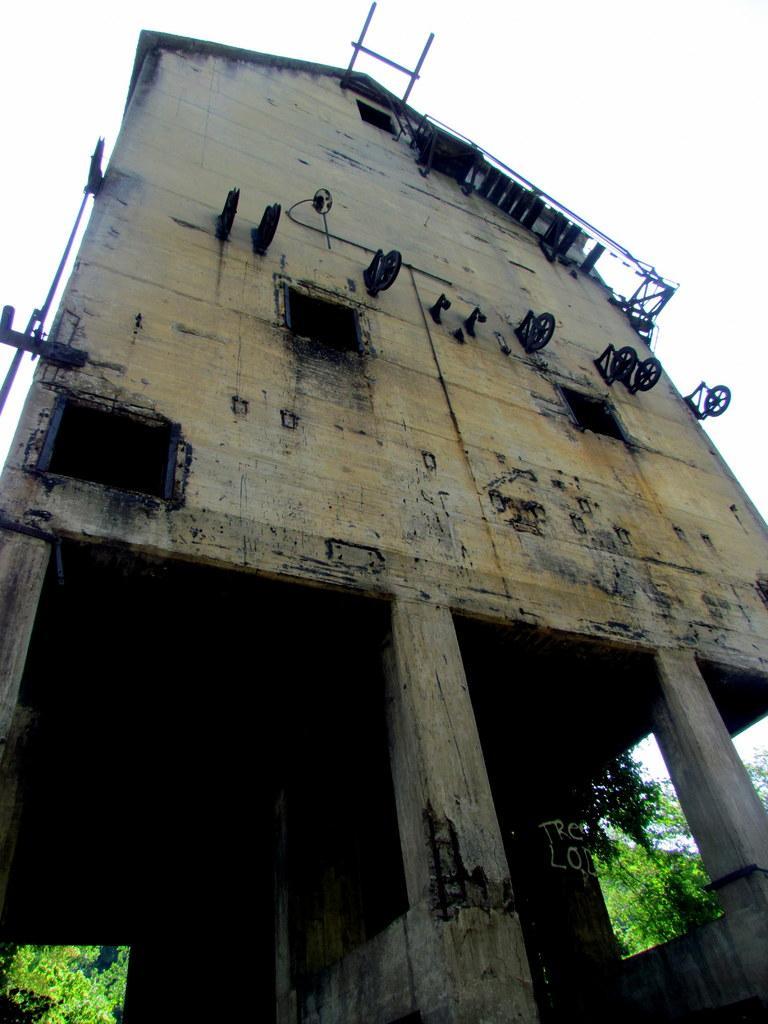In one or two sentences, can you explain what this image depicts? In this picture I can see there is a building and it is an old building, there are few trees and the sky is clear. 